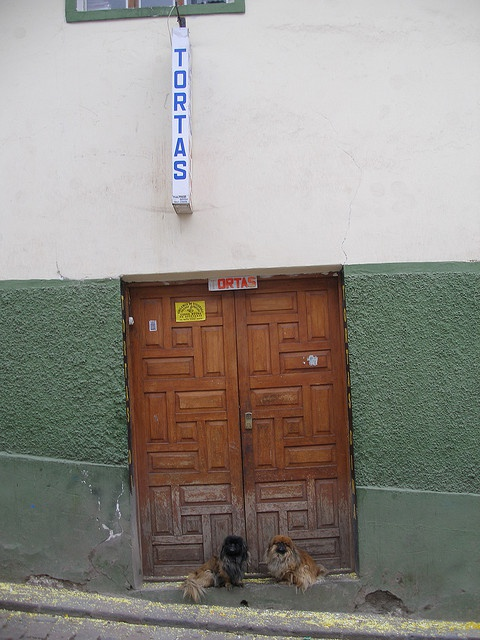Describe the objects in this image and their specific colors. I can see dog in darkgray, black, gray, and maroon tones and dog in darkgray, gray, maroon, and black tones in this image. 